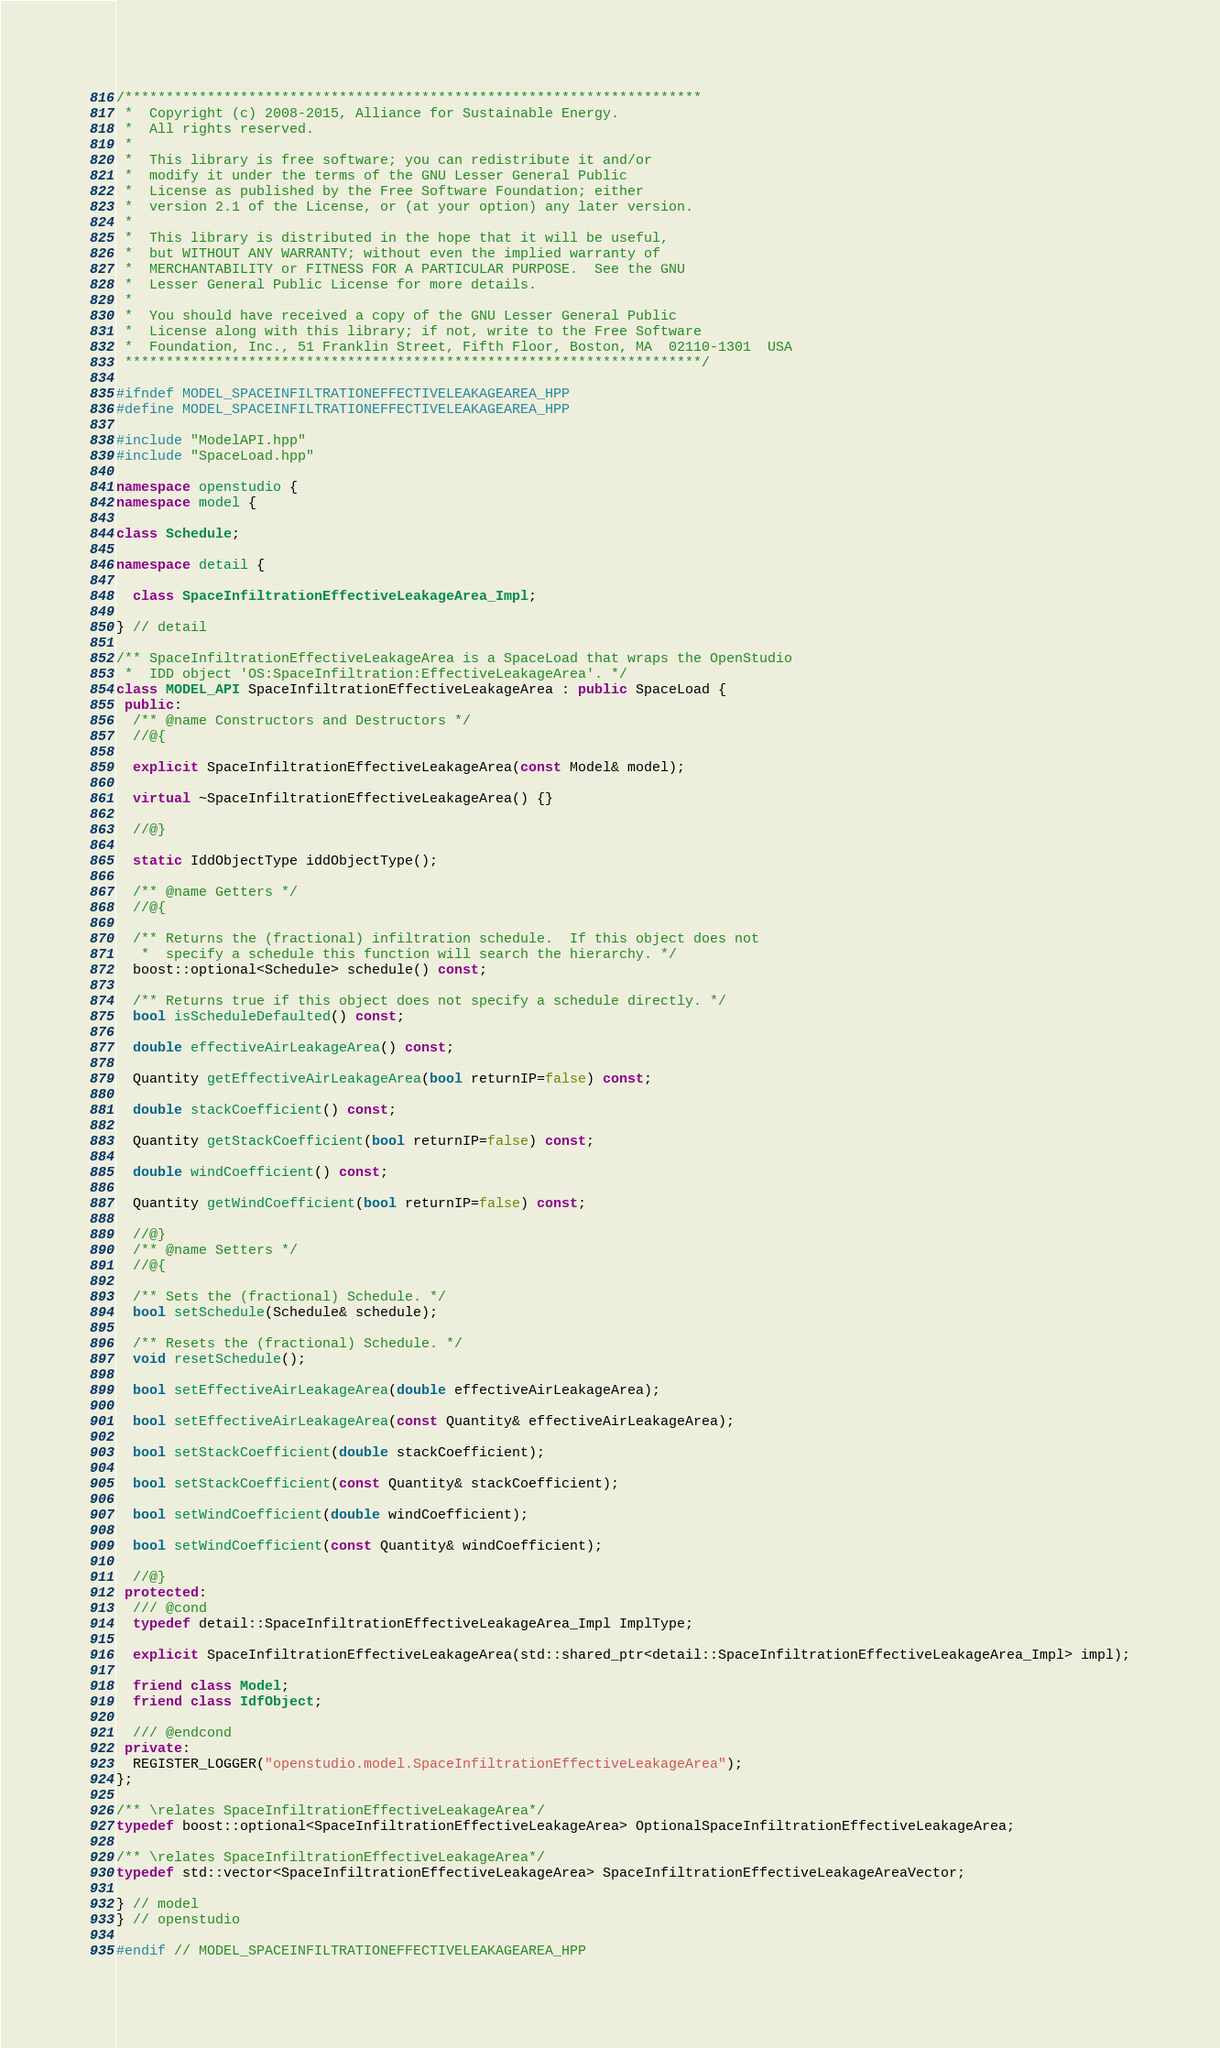Convert code to text. <code><loc_0><loc_0><loc_500><loc_500><_C++_>/**********************************************************************
 *  Copyright (c) 2008-2015, Alliance for Sustainable Energy.
 *  All rights reserved.
 *
 *  This library is free software; you can redistribute it and/or
 *  modify it under the terms of the GNU Lesser General Public
 *  License as published by the Free Software Foundation; either
 *  version 2.1 of the License, or (at your option) any later version.
 *
 *  This library is distributed in the hope that it will be useful,
 *  but WITHOUT ANY WARRANTY; without even the implied warranty of
 *  MERCHANTABILITY or FITNESS FOR A PARTICULAR PURPOSE.  See the GNU
 *  Lesser General Public License for more details.
 *
 *  You should have received a copy of the GNU Lesser General Public
 *  License along with this library; if not, write to the Free Software
 *  Foundation, Inc., 51 Franklin Street, Fifth Floor, Boston, MA  02110-1301  USA
 **********************************************************************/

#ifndef MODEL_SPACEINFILTRATIONEFFECTIVELEAKAGEAREA_HPP
#define MODEL_SPACEINFILTRATIONEFFECTIVELEAKAGEAREA_HPP

#include "ModelAPI.hpp"
#include "SpaceLoad.hpp"

namespace openstudio {
namespace model {

class Schedule;

namespace detail {

  class SpaceInfiltrationEffectiveLeakageArea_Impl;

} // detail

/** SpaceInfiltrationEffectiveLeakageArea is a SpaceLoad that wraps the OpenStudio
 *  IDD object 'OS:SpaceInfiltration:EffectiveLeakageArea'. */
class MODEL_API SpaceInfiltrationEffectiveLeakageArea : public SpaceLoad {
 public:
  /** @name Constructors and Destructors */
  //@{

  explicit SpaceInfiltrationEffectiveLeakageArea(const Model& model);

  virtual ~SpaceInfiltrationEffectiveLeakageArea() {}

  //@}

  static IddObjectType iddObjectType();

  /** @name Getters */
  //@{

  /** Returns the (fractional) infiltration schedule.  If this object does not
   *  specify a schedule this function will search the hierarchy. */
  boost::optional<Schedule> schedule() const;

  /** Returns true if this object does not specify a schedule directly. */
  bool isScheduleDefaulted() const;

  double effectiveAirLeakageArea() const;

  Quantity getEffectiveAirLeakageArea(bool returnIP=false) const;

  double stackCoefficient() const;

  Quantity getStackCoefficient(bool returnIP=false) const;

  double windCoefficient() const;

  Quantity getWindCoefficient(bool returnIP=false) const;

  //@}
  /** @name Setters */
  //@{

  /** Sets the (fractional) Schedule. */
  bool setSchedule(Schedule& schedule);

  /** Resets the (fractional) Schedule. */
  void resetSchedule();

  bool setEffectiveAirLeakageArea(double effectiveAirLeakageArea);

  bool setEffectiveAirLeakageArea(const Quantity& effectiveAirLeakageArea);

  bool setStackCoefficient(double stackCoefficient);

  bool setStackCoefficient(const Quantity& stackCoefficient);

  bool setWindCoefficient(double windCoefficient);

  bool setWindCoefficient(const Quantity& windCoefficient);

  //@}
 protected:
  /// @cond
  typedef detail::SpaceInfiltrationEffectiveLeakageArea_Impl ImplType;

  explicit SpaceInfiltrationEffectiveLeakageArea(std::shared_ptr<detail::SpaceInfiltrationEffectiveLeakageArea_Impl> impl);

  friend class Model;
  friend class IdfObject;

  /// @endcond
 private:
  REGISTER_LOGGER("openstudio.model.SpaceInfiltrationEffectiveLeakageArea");
};

/** \relates SpaceInfiltrationEffectiveLeakageArea*/
typedef boost::optional<SpaceInfiltrationEffectiveLeakageArea> OptionalSpaceInfiltrationEffectiveLeakageArea;

/** \relates SpaceInfiltrationEffectiveLeakageArea*/
typedef std::vector<SpaceInfiltrationEffectiveLeakageArea> SpaceInfiltrationEffectiveLeakageAreaVector;

} // model
} // openstudio

#endif // MODEL_SPACEINFILTRATIONEFFECTIVELEAKAGEAREA_HPP

</code> 